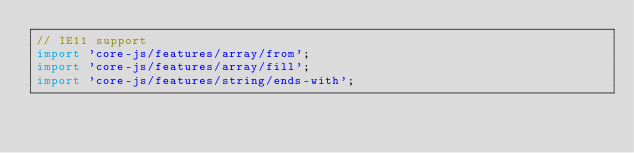Convert code to text. <code><loc_0><loc_0><loc_500><loc_500><_JavaScript_>// IE11 support
import 'core-js/features/array/from';
import 'core-js/features/array/fill';
import 'core-js/features/string/ends-with';
</code> 